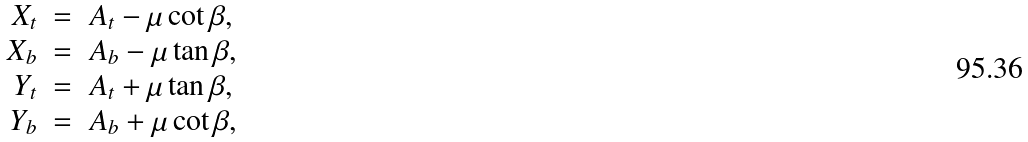<formula> <loc_0><loc_0><loc_500><loc_500>\begin{array} { r c l } X _ { t } & = & A _ { t } - \mu \cot \beta , \\ X _ { b } & = & A _ { b } - \mu \tan \beta , \\ Y _ { t } & = & A _ { t } + \mu \tan \beta , \\ Y _ { b } & = & A _ { b } + \mu \cot \beta , \end{array}</formula> 